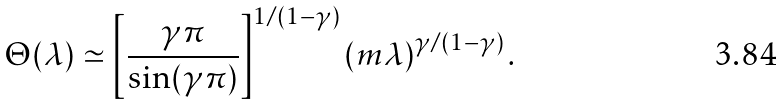<formula> <loc_0><loc_0><loc_500><loc_500>\Theta ( \lambda ) \simeq \left [ \frac { \gamma \pi } { \sin ( \gamma \pi ) } \right ] ^ { 1 / ( 1 - \gamma ) } \left ( m \lambda \right ) ^ { \gamma / ( 1 - \gamma ) } .</formula> 